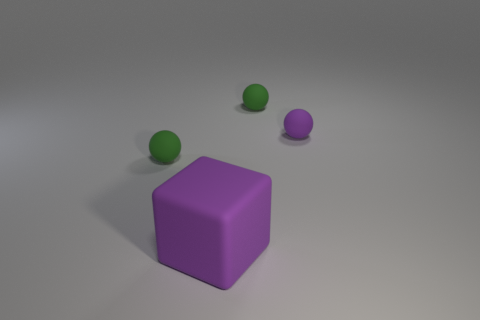What material is the tiny ball that is the same color as the big rubber object?
Ensure brevity in your answer.  Rubber. What is the thing that is both behind the big purple block and in front of the purple matte sphere made of?
Your response must be concise. Rubber. There is a tiny green sphere that is to the right of the large purple object; are there any big purple rubber things that are behind it?
Give a very brief answer. No. There is a object that is both on the left side of the tiny purple thing and to the right of the cube; what size is it?
Give a very brief answer. Small. How many green objects are either large matte objects or tiny objects?
Give a very brief answer. 2. What number of other objects are the same color as the large object?
Provide a succinct answer. 1. There is a green ball that is in front of the small purple rubber object that is right of the purple block; how big is it?
Your answer should be very brief. Small. Are the ball left of the big matte block and the large purple cube made of the same material?
Keep it short and to the point. Yes. What shape is the tiny green matte object to the left of the purple matte cube?
Make the answer very short. Sphere. What number of green rubber objects are the same size as the rubber block?
Make the answer very short. 0. 